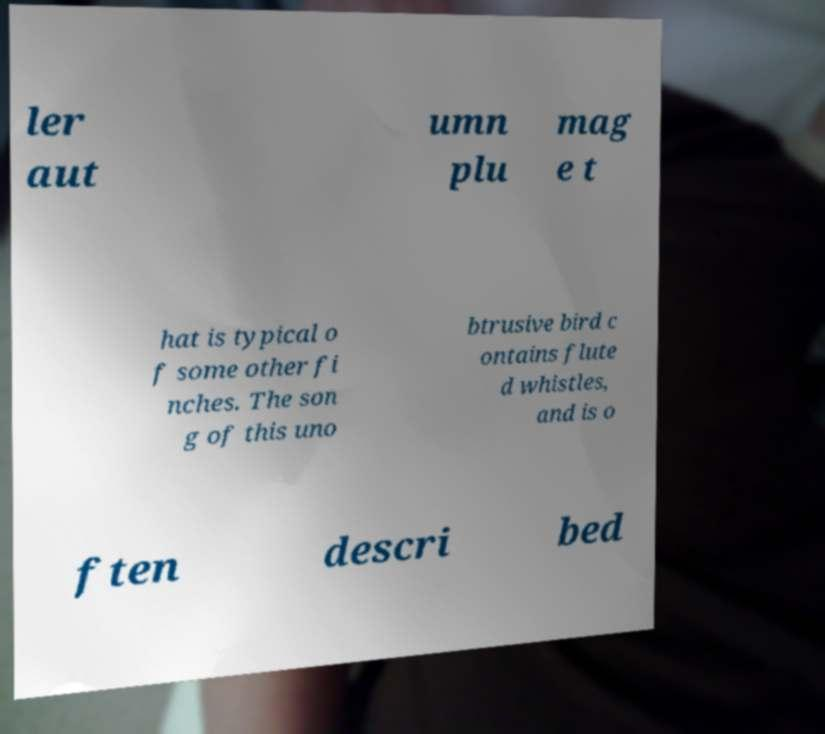Could you extract and type out the text from this image? ler aut umn plu mag e t hat is typical o f some other fi nches. The son g of this uno btrusive bird c ontains flute d whistles, and is o ften descri bed 